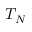Convert formula to latex. <formula><loc_0><loc_0><loc_500><loc_500>T _ { N }</formula> 